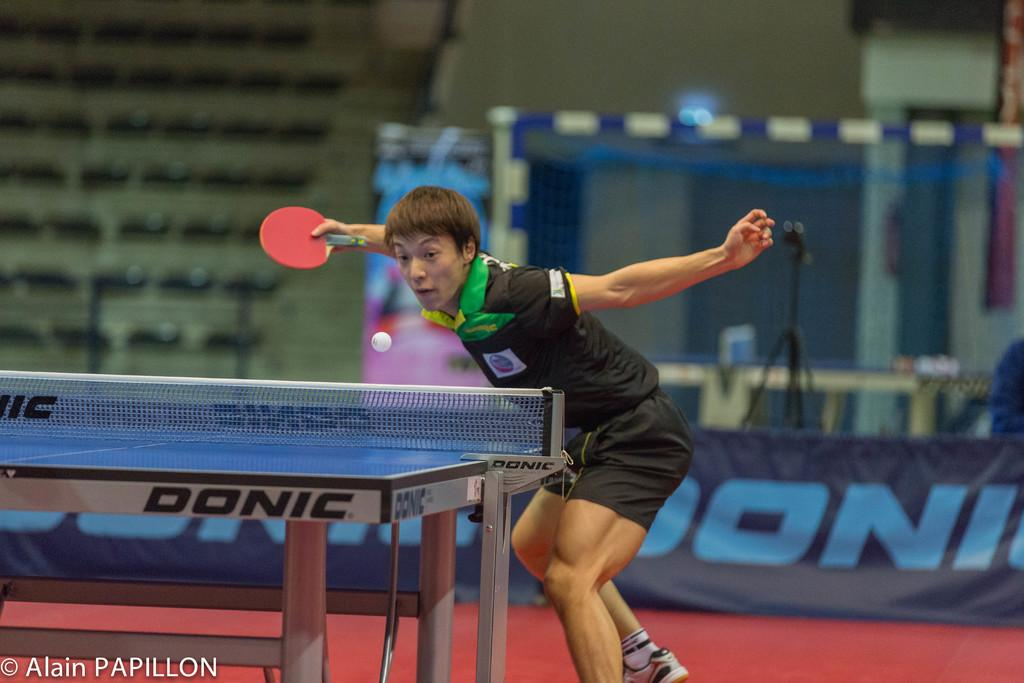Who is present in the image? There is a man in the image. What is the man holding in the image? The man is holding a bat in the image. What other object can be seen in the image? There is a ball in the image. What is in front of the man in the image? There is a table in front of the man in the image. What can be seen in the background of the image? There is a banner in the background of the image. What direction is the man coughing in the image? There is no indication of the man coughing in the image. 